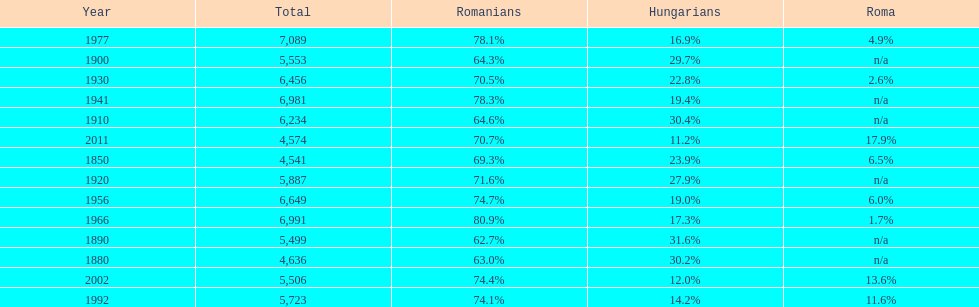What year had the highest total number? 1977. 